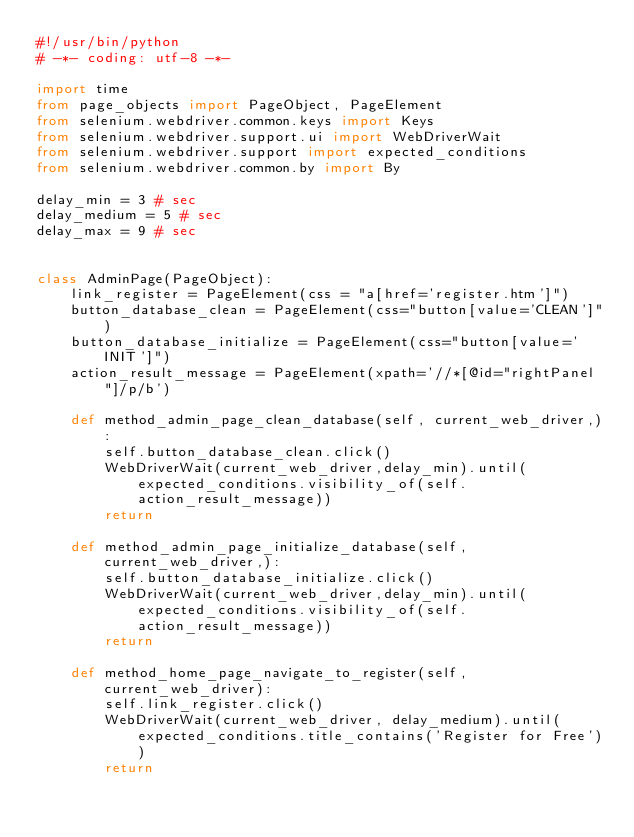Convert code to text. <code><loc_0><loc_0><loc_500><loc_500><_Python_>#!/usr/bin/python
# -*- coding: utf-8 -*-

import time
from page_objects import PageObject, PageElement
from selenium.webdriver.common.keys import Keys
from selenium.webdriver.support.ui import WebDriverWait
from selenium.webdriver.support import expected_conditions
from selenium.webdriver.common.by import By

delay_min = 3 # sec
delay_medium = 5 # sec
delay_max = 9 # sec


class AdminPage(PageObject):
    link_register = PageElement(css = "a[href='register.htm']")
    button_database_clean = PageElement(css="button[value='CLEAN']")
    button_database_initialize = PageElement(css="button[value='INIT']")
    action_result_message = PageElement(xpath='//*[@id="rightPanel"]/p/b')

    def method_admin_page_clean_database(self, current_web_driver,):
        self.button_database_clean.click()
        WebDriverWait(current_web_driver,delay_min).until(expected_conditions.visibility_of(self.action_result_message))
        return

    def method_admin_page_initialize_database(self, current_web_driver,):
        self.button_database_initialize.click()
        WebDriverWait(current_web_driver,delay_min).until(expected_conditions.visibility_of(self.action_result_message))
        return

    def method_home_page_navigate_to_register(self, current_web_driver):
        self.link_register.click()
        WebDriverWait(current_web_driver, delay_medium).until(expected_conditions.title_contains('Register for Free'))
        return
</code> 